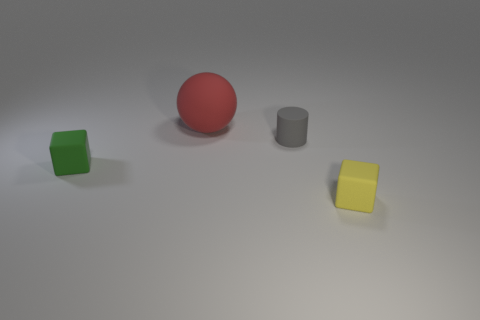Is there anything else of the same color as the big matte sphere?
Make the answer very short. No. There is a small green thing that is made of the same material as the small yellow thing; what is its shape?
Keep it short and to the point. Cube. Is the rubber cylinder the same size as the green matte block?
Provide a succinct answer. Yes. Are the tiny block that is behind the yellow object and the tiny gray thing made of the same material?
Give a very brief answer. Yes. There is a thing in front of the tiny rubber cube behind the small yellow block; how many large red balls are behind it?
Provide a succinct answer. 1. There is a matte object that is right of the matte cylinder; does it have the same shape as the red object?
Your response must be concise. No. How many things are cyan shiny cubes or tiny objects right of the big red matte sphere?
Provide a succinct answer. 2. Are there more tiny green matte things that are in front of the green matte thing than yellow cylinders?
Offer a very short reply. No. Are there an equal number of large matte objects left of the matte cylinder and yellow rubber things that are behind the green block?
Make the answer very short. No. Are there any small green things in front of the tiny rubber object that is behind the green block?
Give a very brief answer. Yes. 